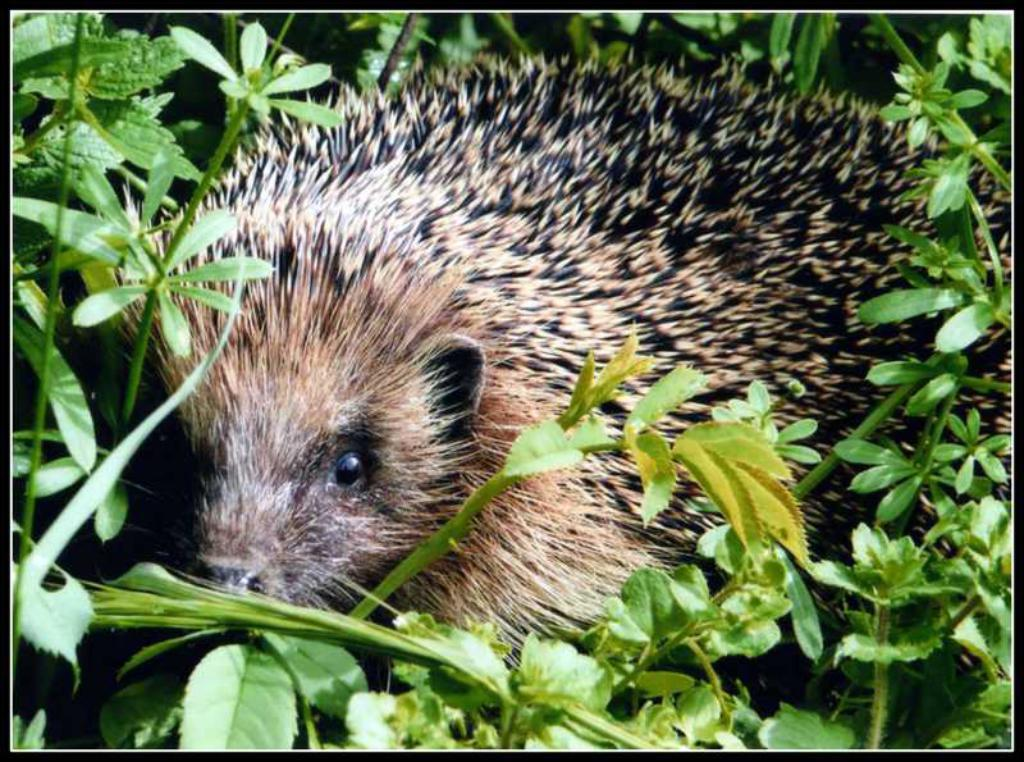What type of living organisms can be seen in the image? Plants are visible in the image. What other living organism can be seen in the image? There is an animal in the image. How can the image be described in terms of its layout? The image has borders. What type of coast can be seen in the image? There is no coast visible in the image; it features plants and an animal. What need does the animal have in the image? The image does not provide information about the animal's needs. 